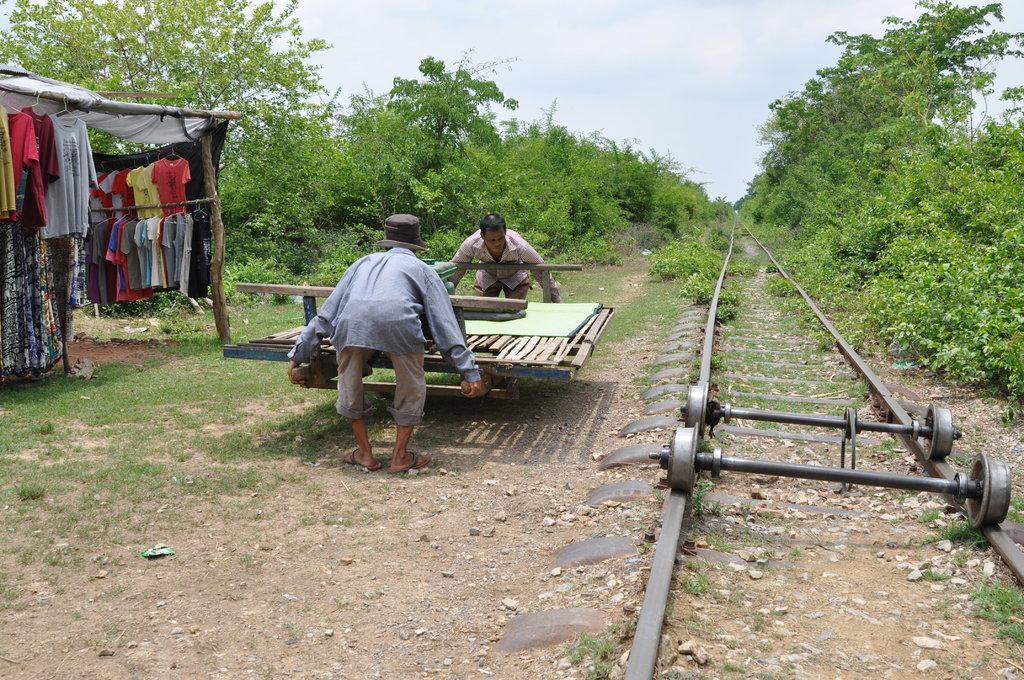Can you describe this image briefly? In this image there is a track. We can see iron rods. There are people. There is wooden object. There are grass, sand and stones. We can see many trees. There is a clothes stall on the left side. There is sky. 